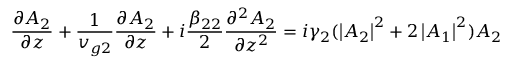Convert formula to latex. <formula><loc_0><loc_0><loc_500><loc_500>\frac { \partial A _ { 2 } } { \partial z } + \frac { 1 } { v _ { g 2 } } \frac { \partial A _ { 2 } } { \partial z } + i \frac { \beta _ { 2 2 } } { 2 } \frac { \partial ^ { 2 } A _ { 2 } } { \partial z ^ { 2 } } = i \gamma _ { 2 } ( \left | A _ { 2 } \right | ^ { 2 } + 2 \left | A _ { 1 } \right | ^ { 2 } ) A _ { 2 }</formula> 